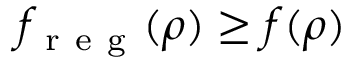Convert formula to latex. <formula><loc_0><loc_0><loc_500><loc_500>f _ { r e g } ( \rho ) \geq f ( \rho )</formula> 